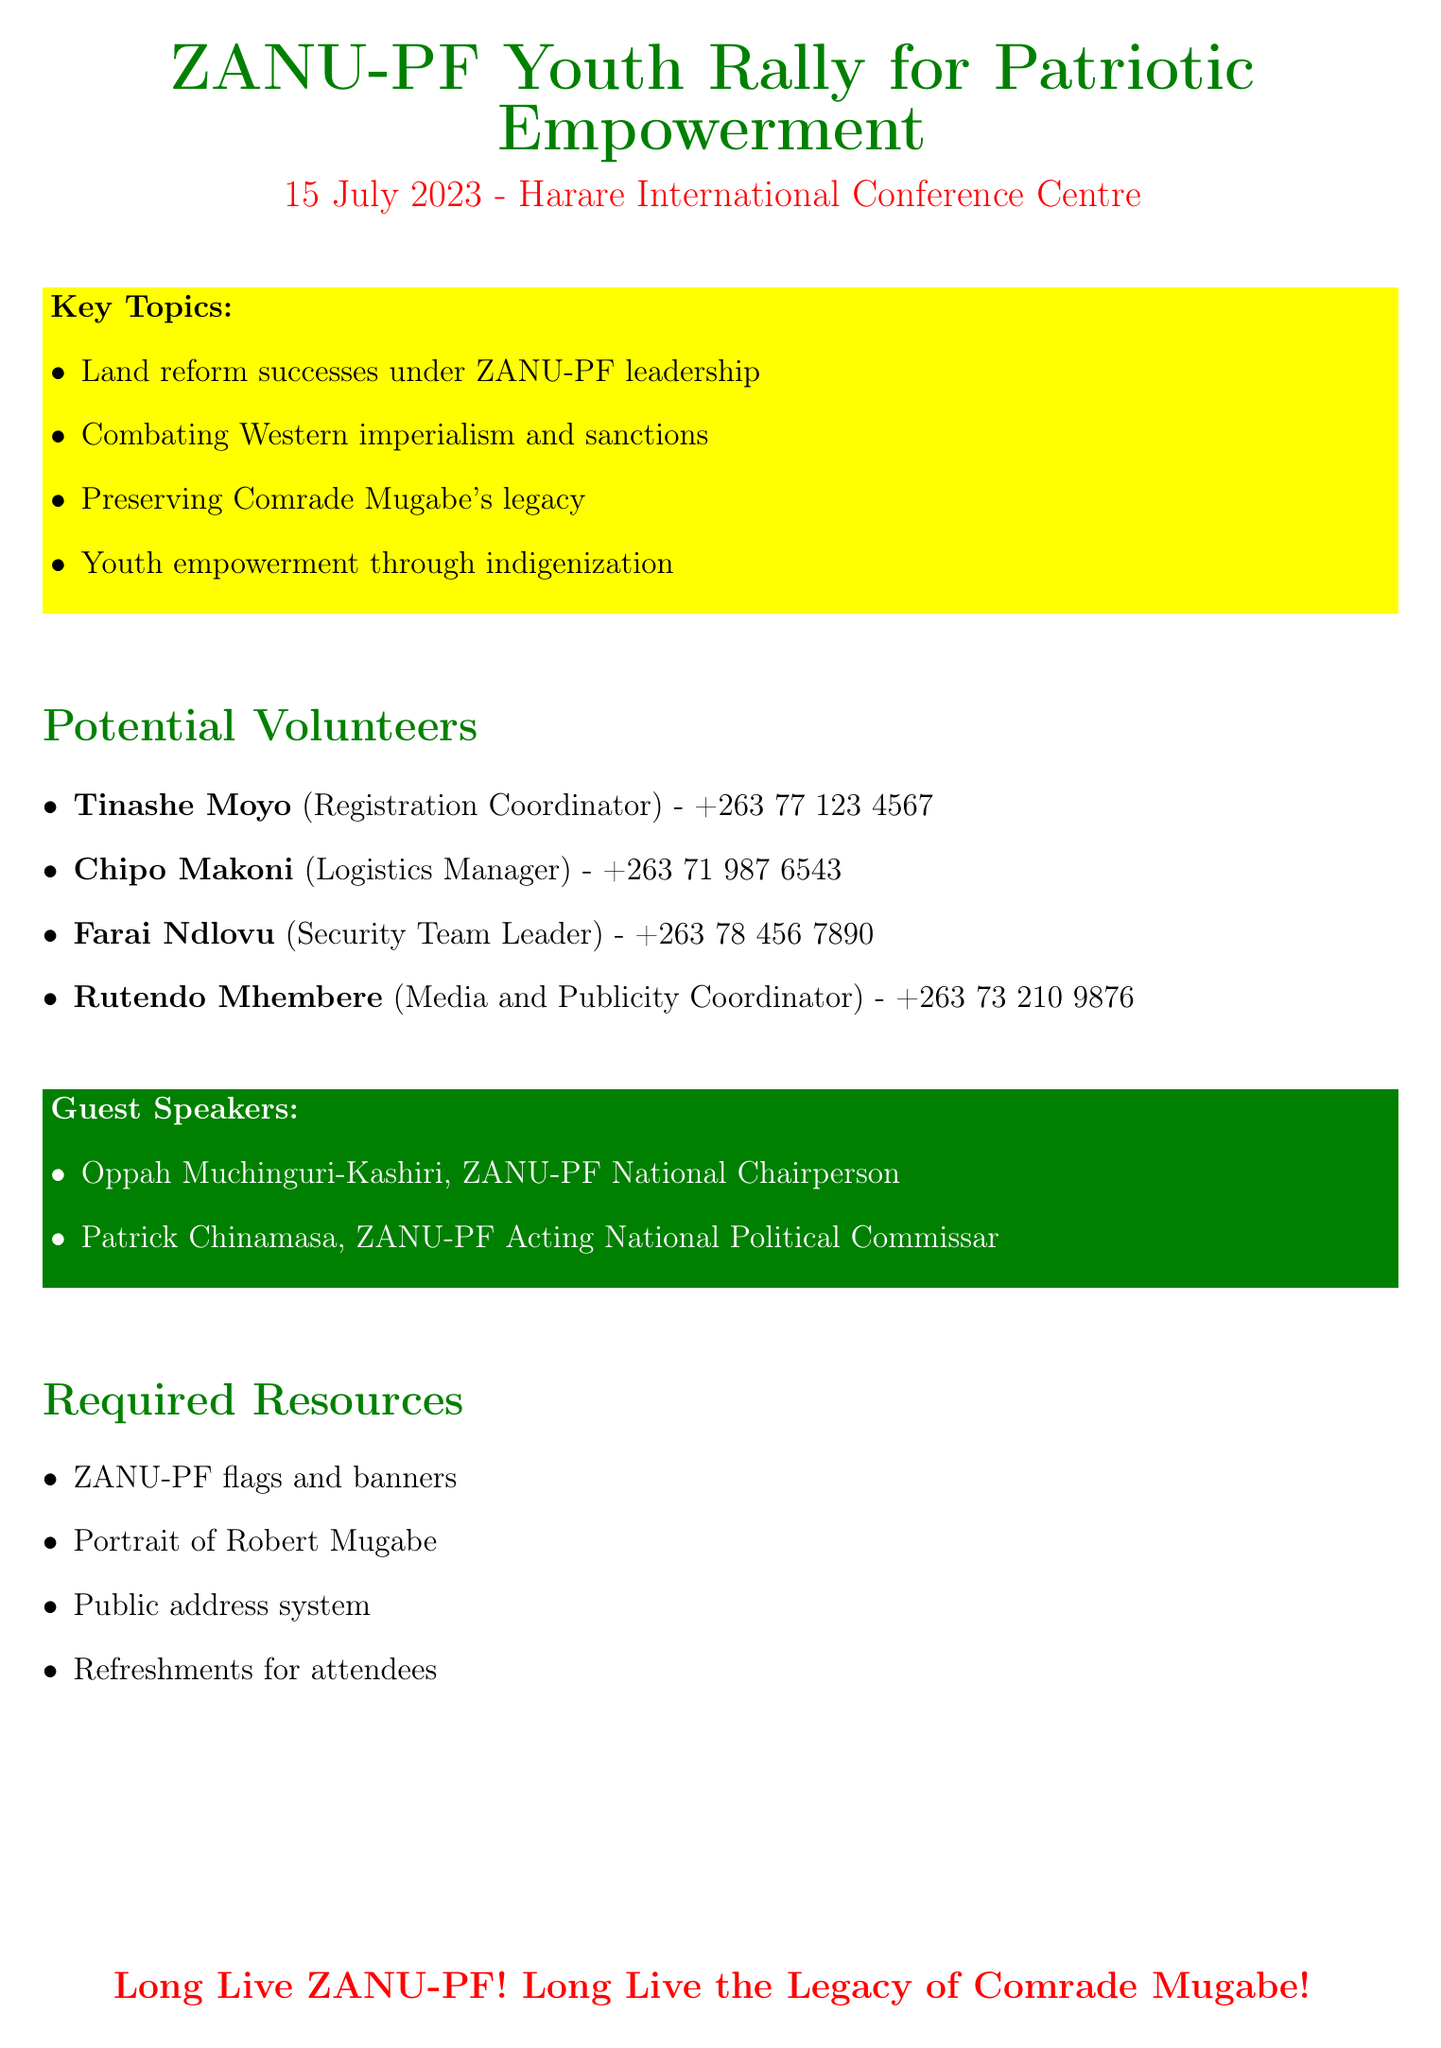What is the event title? The event title can be found at the beginning of the document, which is "ZANU-PF Youth Rally for Patriotic Empowerment."
Answer: ZANU-PF Youth Rally for Patriotic Empowerment What is the date of the event? The date of the event is specifically mentioned in the document as "15 July 2023."
Answer: 15 July 2023 Who is the Registration Coordinator? The document lists Tinashe Moyo as the individual responsible for registration, identified by their role.
Answer: Tinashe Moyo What role does Chipo Makoni serve? Chipo Makoni's role is explicitly stated as "Logistics Manager" in the document.
Answer: Logistics Manager How many guest speakers are listed? The number of guest speakers is counted from the list provided, which includes two names.
Answer: 2 What is one key topic discussed at the event? One of the highlighted key topics is "Youth empowerment through indigenization," which is listed in the document.
Answer: Youth empowerment through indigenization What affiliation does Farai Ndlovu have? Farai Ndlovu's affiliation is mentioned directly as "National Youth Service Graduate" in the document.
Answer: National Youth Service Graduate What is one of the required resources for the event? The document states specific resources needed, one of which is "Public address system."
Answer: Public address system Who is the ZANU-PF National Chairperson? The document names Oppah Muchinguri-Kashiri as the ZANU-PF National Chairperson.
Answer: Oppah Muchinguri-Kashiri 